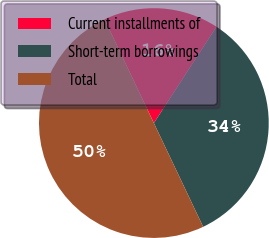Convert chart. <chart><loc_0><loc_0><loc_500><loc_500><pie_chart><fcel>Current installments of<fcel>Short-term borrowings<fcel>Total<nl><fcel>16.23%<fcel>33.77%<fcel>50.0%<nl></chart> 